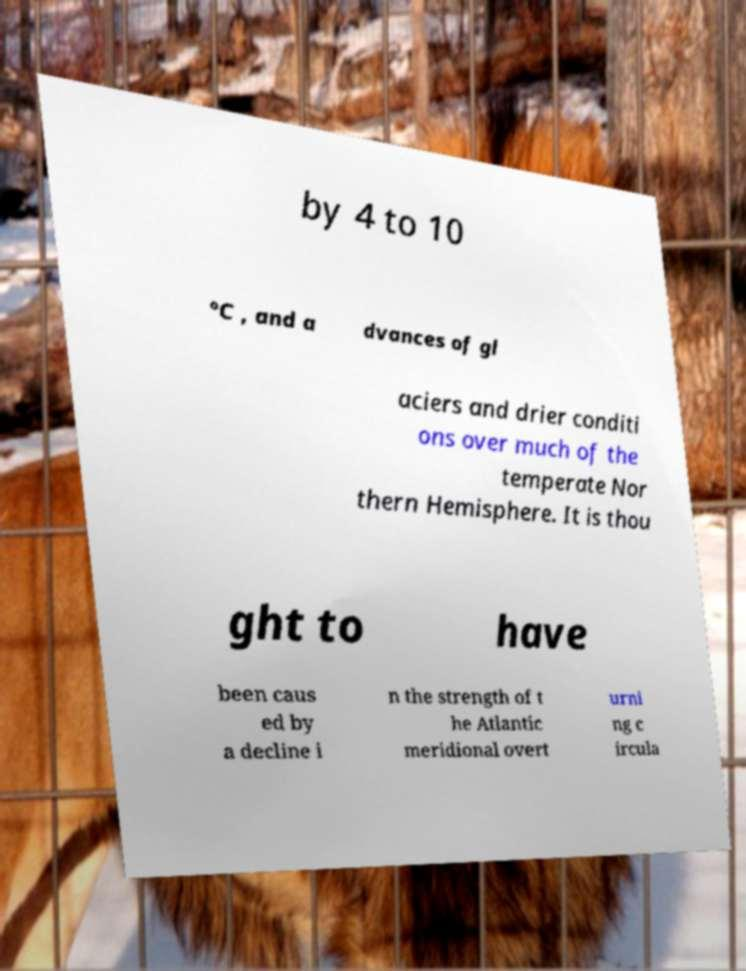Please identify and transcribe the text found in this image. by 4 to 10 °C , and a dvances of gl aciers and drier conditi ons over much of the temperate Nor thern Hemisphere. It is thou ght to have been caus ed by a decline i n the strength of t he Atlantic meridional overt urni ng c ircula 